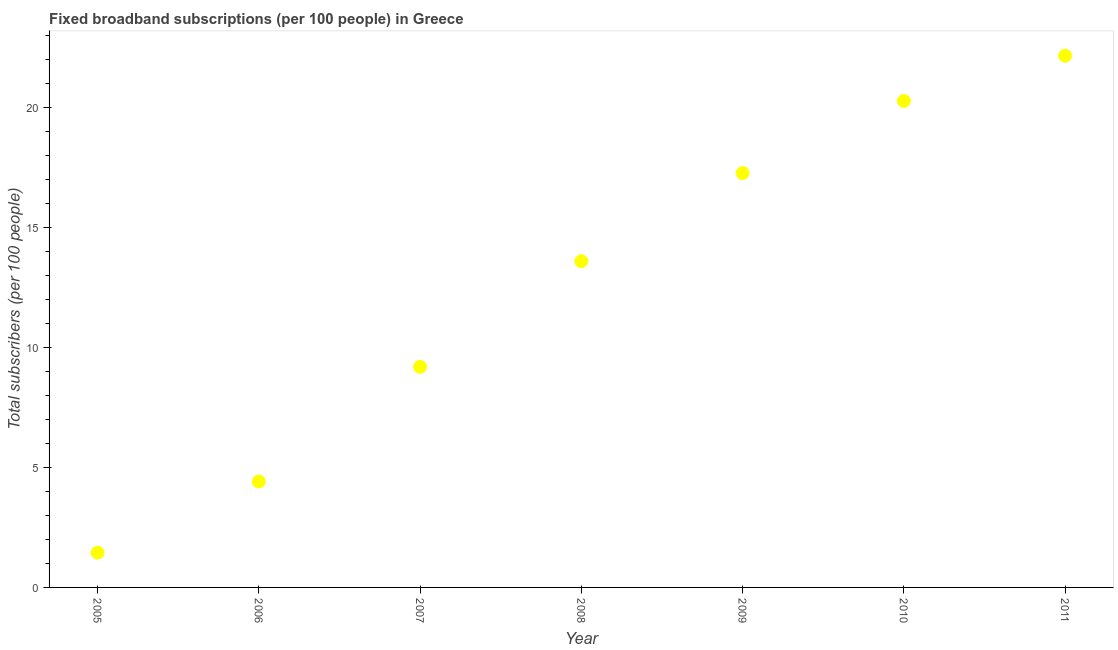What is the total number of fixed broadband subscriptions in 2008?
Provide a short and direct response. 13.6. Across all years, what is the maximum total number of fixed broadband subscriptions?
Give a very brief answer. 22.16. Across all years, what is the minimum total number of fixed broadband subscriptions?
Offer a terse response. 1.45. In which year was the total number of fixed broadband subscriptions maximum?
Your answer should be compact. 2011. What is the sum of the total number of fixed broadband subscriptions?
Your answer should be compact. 88.37. What is the difference between the total number of fixed broadband subscriptions in 2010 and 2011?
Ensure brevity in your answer.  -1.89. What is the average total number of fixed broadband subscriptions per year?
Give a very brief answer. 12.62. What is the median total number of fixed broadband subscriptions?
Your response must be concise. 13.6. In how many years, is the total number of fixed broadband subscriptions greater than 7 ?
Give a very brief answer. 5. What is the ratio of the total number of fixed broadband subscriptions in 2007 to that in 2009?
Your answer should be compact. 0.53. Is the total number of fixed broadband subscriptions in 2009 less than that in 2011?
Make the answer very short. Yes. Is the difference between the total number of fixed broadband subscriptions in 2006 and 2011 greater than the difference between any two years?
Make the answer very short. No. What is the difference between the highest and the second highest total number of fixed broadband subscriptions?
Offer a terse response. 1.89. What is the difference between the highest and the lowest total number of fixed broadband subscriptions?
Offer a terse response. 20.71. What is the difference between two consecutive major ticks on the Y-axis?
Your answer should be very brief. 5. Are the values on the major ticks of Y-axis written in scientific E-notation?
Keep it short and to the point. No. Does the graph contain grids?
Ensure brevity in your answer.  No. What is the title of the graph?
Your answer should be compact. Fixed broadband subscriptions (per 100 people) in Greece. What is the label or title of the X-axis?
Ensure brevity in your answer.  Year. What is the label or title of the Y-axis?
Your answer should be compact. Total subscribers (per 100 people). What is the Total subscribers (per 100 people) in 2005?
Your response must be concise. 1.45. What is the Total subscribers (per 100 people) in 2006?
Offer a very short reply. 4.42. What is the Total subscribers (per 100 people) in 2007?
Provide a short and direct response. 9.19. What is the Total subscribers (per 100 people) in 2008?
Keep it short and to the point. 13.6. What is the Total subscribers (per 100 people) in 2009?
Ensure brevity in your answer.  17.27. What is the Total subscribers (per 100 people) in 2010?
Give a very brief answer. 20.28. What is the Total subscribers (per 100 people) in 2011?
Make the answer very short. 22.16. What is the difference between the Total subscribers (per 100 people) in 2005 and 2006?
Give a very brief answer. -2.97. What is the difference between the Total subscribers (per 100 people) in 2005 and 2007?
Your response must be concise. -7.74. What is the difference between the Total subscribers (per 100 people) in 2005 and 2008?
Your answer should be very brief. -12.15. What is the difference between the Total subscribers (per 100 people) in 2005 and 2009?
Your answer should be compact. -15.82. What is the difference between the Total subscribers (per 100 people) in 2005 and 2010?
Offer a terse response. -18.83. What is the difference between the Total subscribers (per 100 people) in 2005 and 2011?
Provide a succinct answer. -20.71. What is the difference between the Total subscribers (per 100 people) in 2006 and 2007?
Ensure brevity in your answer.  -4.78. What is the difference between the Total subscribers (per 100 people) in 2006 and 2008?
Your response must be concise. -9.18. What is the difference between the Total subscribers (per 100 people) in 2006 and 2009?
Your answer should be compact. -12.85. What is the difference between the Total subscribers (per 100 people) in 2006 and 2010?
Keep it short and to the point. -15.86. What is the difference between the Total subscribers (per 100 people) in 2006 and 2011?
Keep it short and to the point. -17.75. What is the difference between the Total subscribers (per 100 people) in 2007 and 2008?
Keep it short and to the point. -4.4. What is the difference between the Total subscribers (per 100 people) in 2007 and 2009?
Your answer should be very brief. -8.08. What is the difference between the Total subscribers (per 100 people) in 2007 and 2010?
Provide a short and direct response. -11.08. What is the difference between the Total subscribers (per 100 people) in 2007 and 2011?
Offer a very short reply. -12.97. What is the difference between the Total subscribers (per 100 people) in 2008 and 2009?
Your response must be concise. -3.67. What is the difference between the Total subscribers (per 100 people) in 2008 and 2010?
Provide a succinct answer. -6.68. What is the difference between the Total subscribers (per 100 people) in 2008 and 2011?
Keep it short and to the point. -8.57. What is the difference between the Total subscribers (per 100 people) in 2009 and 2010?
Offer a very short reply. -3.01. What is the difference between the Total subscribers (per 100 people) in 2009 and 2011?
Offer a terse response. -4.89. What is the difference between the Total subscribers (per 100 people) in 2010 and 2011?
Make the answer very short. -1.89. What is the ratio of the Total subscribers (per 100 people) in 2005 to that in 2006?
Your answer should be very brief. 0.33. What is the ratio of the Total subscribers (per 100 people) in 2005 to that in 2007?
Ensure brevity in your answer.  0.16. What is the ratio of the Total subscribers (per 100 people) in 2005 to that in 2008?
Keep it short and to the point. 0.11. What is the ratio of the Total subscribers (per 100 people) in 2005 to that in 2009?
Provide a succinct answer. 0.08. What is the ratio of the Total subscribers (per 100 people) in 2005 to that in 2010?
Make the answer very short. 0.07. What is the ratio of the Total subscribers (per 100 people) in 2005 to that in 2011?
Your response must be concise. 0.07. What is the ratio of the Total subscribers (per 100 people) in 2006 to that in 2007?
Offer a very short reply. 0.48. What is the ratio of the Total subscribers (per 100 people) in 2006 to that in 2008?
Provide a succinct answer. 0.33. What is the ratio of the Total subscribers (per 100 people) in 2006 to that in 2009?
Make the answer very short. 0.26. What is the ratio of the Total subscribers (per 100 people) in 2006 to that in 2010?
Your response must be concise. 0.22. What is the ratio of the Total subscribers (per 100 people) in 2006 to that in 2011?
Offer a very short reply. 0.2. What is the ratio of the Total subscribers (per 100 people) in 2007 to that in 2008?
Your answer should be very brief. 0.68. What is the ratio of the Total subscribers (per 100 people) in 2007 to that in 2009?
Provide a succinct answer. 0.53. What is the ratio of the Total subscribers (per 100 people) in 2007 to that in 2010?
Offer a very short reply. 0.45. What is the ratio of the Total subscribers (per 100 people) in 2007 to that in 2011?
Offer a very short reply. 0.41. What is the ratio of the Total subscribers (per 100 people) in 2008 to that in 2009?
Your answer should be compact. 0.79. What is the ratio of the Total subscribers (per 100 people) in 2008 to that in 2010?
Your answer should be compact. 0.67. What is the ratio of the Total subscribers (per 100 people) in 2008 to that in 2011?
Give a very brief answer. 0.61. What is the ratio of the Total subscribers (per 100 people) in 2009 to that in 2010?
Provide a succinct answer. 0.85. What is the ratio of the Total subscribers (per 100 people) in 2009 to that in 2011?
Give a very brief answer. 0.78. What is the ratio of the Total subscribers (per 100 people) in 2010 to that in 2011?
Give a very brief answer. 0.92. 